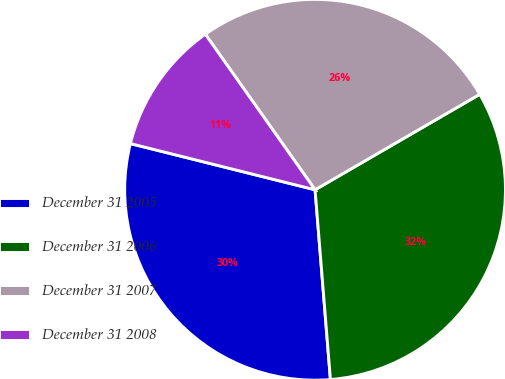Convert chart. <chart><loc_0><loc_0><loc_500><loc_500><pie_chart><fcel>December 31 2005<fcel>December 31 2006<fcel>December 31 2007<fcel>December 31 2008<nl><fcel>30.19%<fcel>32.08%<fcel>26.42%<fcel>11.32%<nl></chart> 